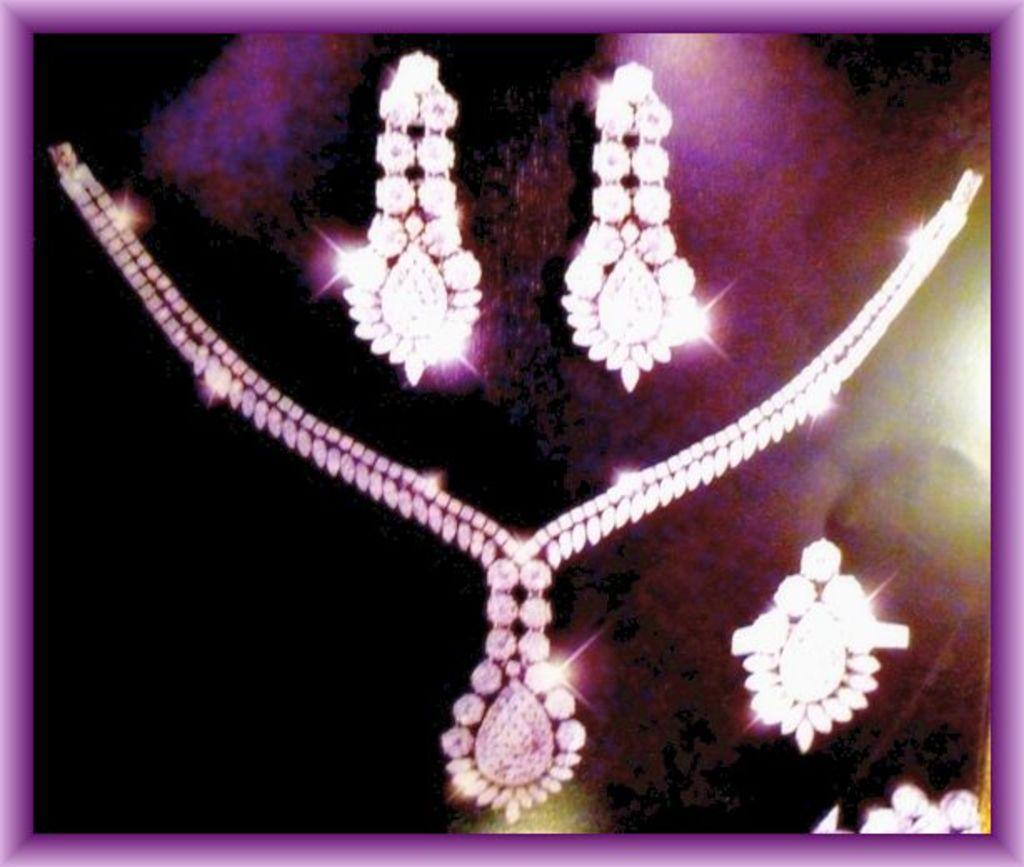What type of items can be seen in the image? There is jewelry in the image. What color is the background of the image? The background of the image is violet. What type of medical advice can be heard from the doctor in the image? There is no doctor present in the image, so no medical advice can be heard. 